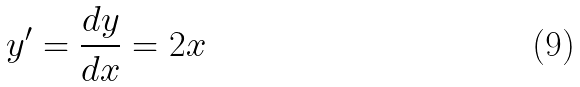Convert formula to latex. <formula><loc_0><loc_0><loc_500><loc_500>y ^ { \prime } = \frac { d y } { d x } = 2 x</formula> 